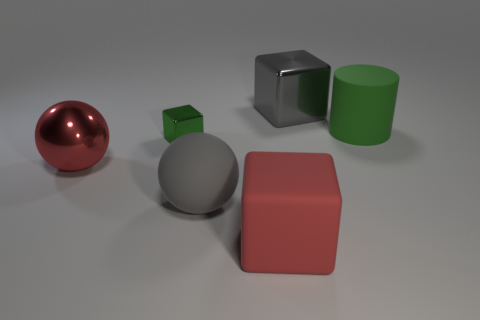Subtract all large cubes. How many cubes are left? 1 Add 2 large rubber cubes. How many objects exist? 8 Subtract all green blocks. How many blocks are left? 2 Subtract all balls. How many objects are left? 4 Subtract all cyan metal cylinders. Subtract all shiny blocks. How many objects are left? 4 Add 1 large matte blocks. How many large matte blocks are left? 2 Add 3 large green shiny cylinders. How many large green shiny cylinders exist? 3 Subtract 0 purple balls. How many objects are left? 6 Subtract all blue blocks. Subtract all red balls. How many blocks are left? 3 